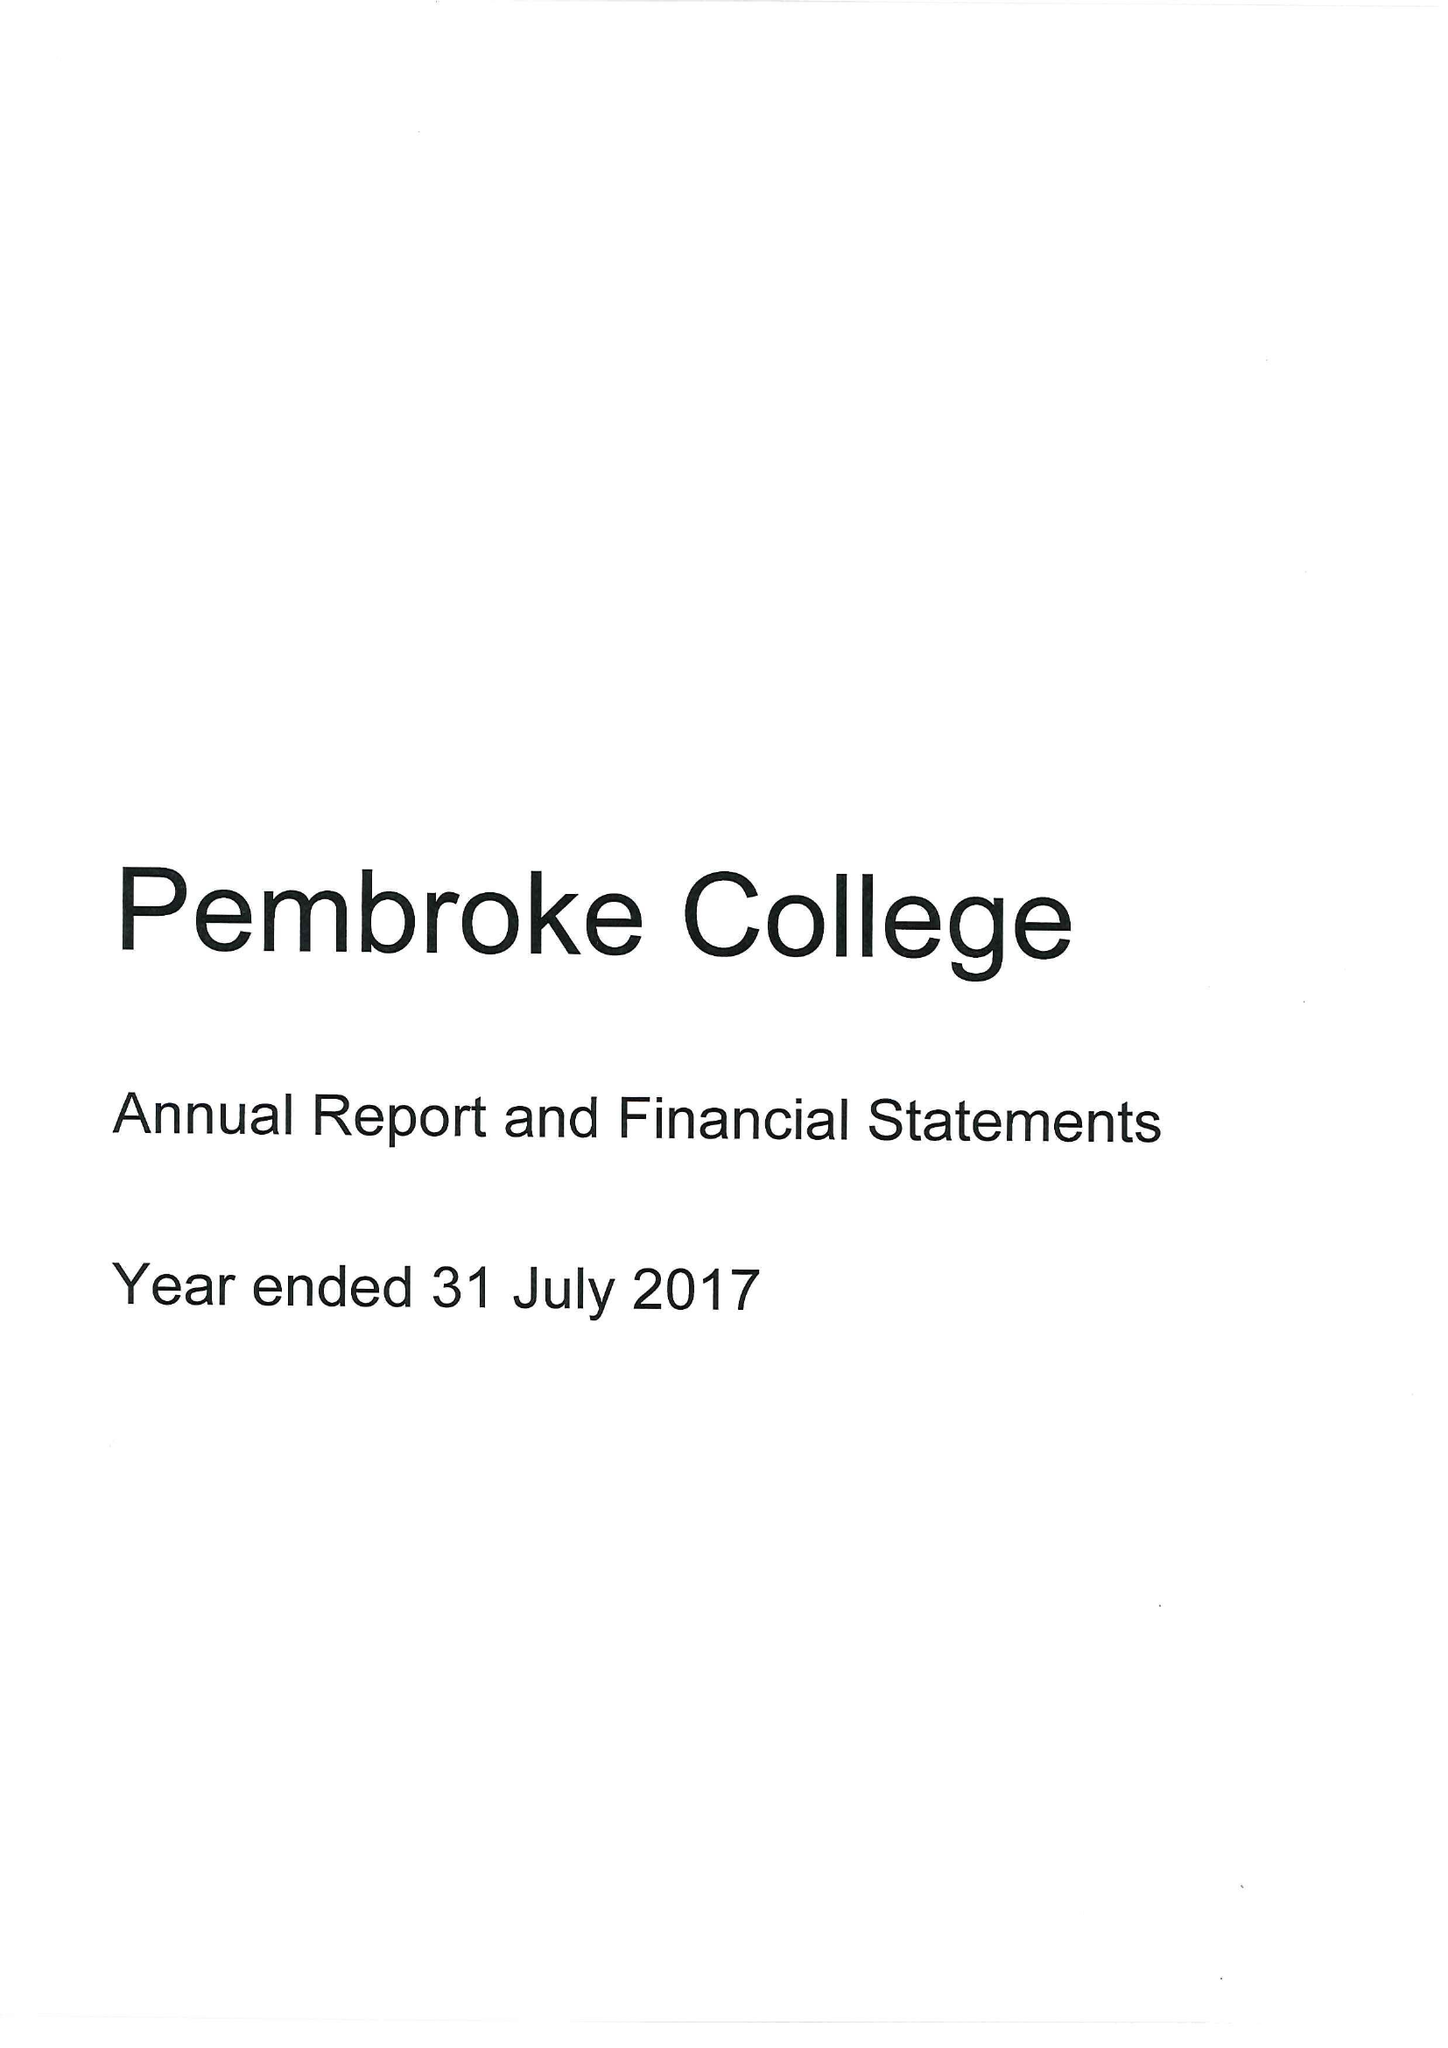What is the value for the address__post_town?
Answer the question using a single word or phrase. OXFORD 